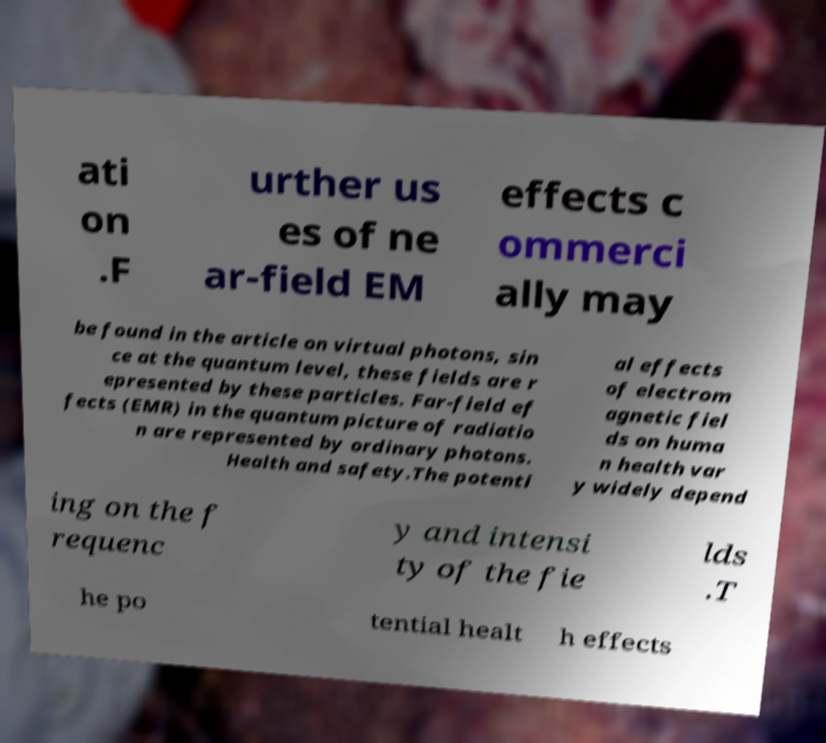Please identify and transcribe the text found in this image. ati on .F urther us es of ne ar-field EM effects c ommerci ally may be found in the article on virtual photons, sin ce at the quantum level, these fields are r epresented by these particles. Far-field ef fects (EMR) in the quantum picture of radiatio n are represented by ordinary photons. Health and safety.The potenti al effects of electrom agnetic fiel ds on huma n health var y widely depend ing on the f requenc y and intensi ty of the fie lds .T he po tential healt h effects 